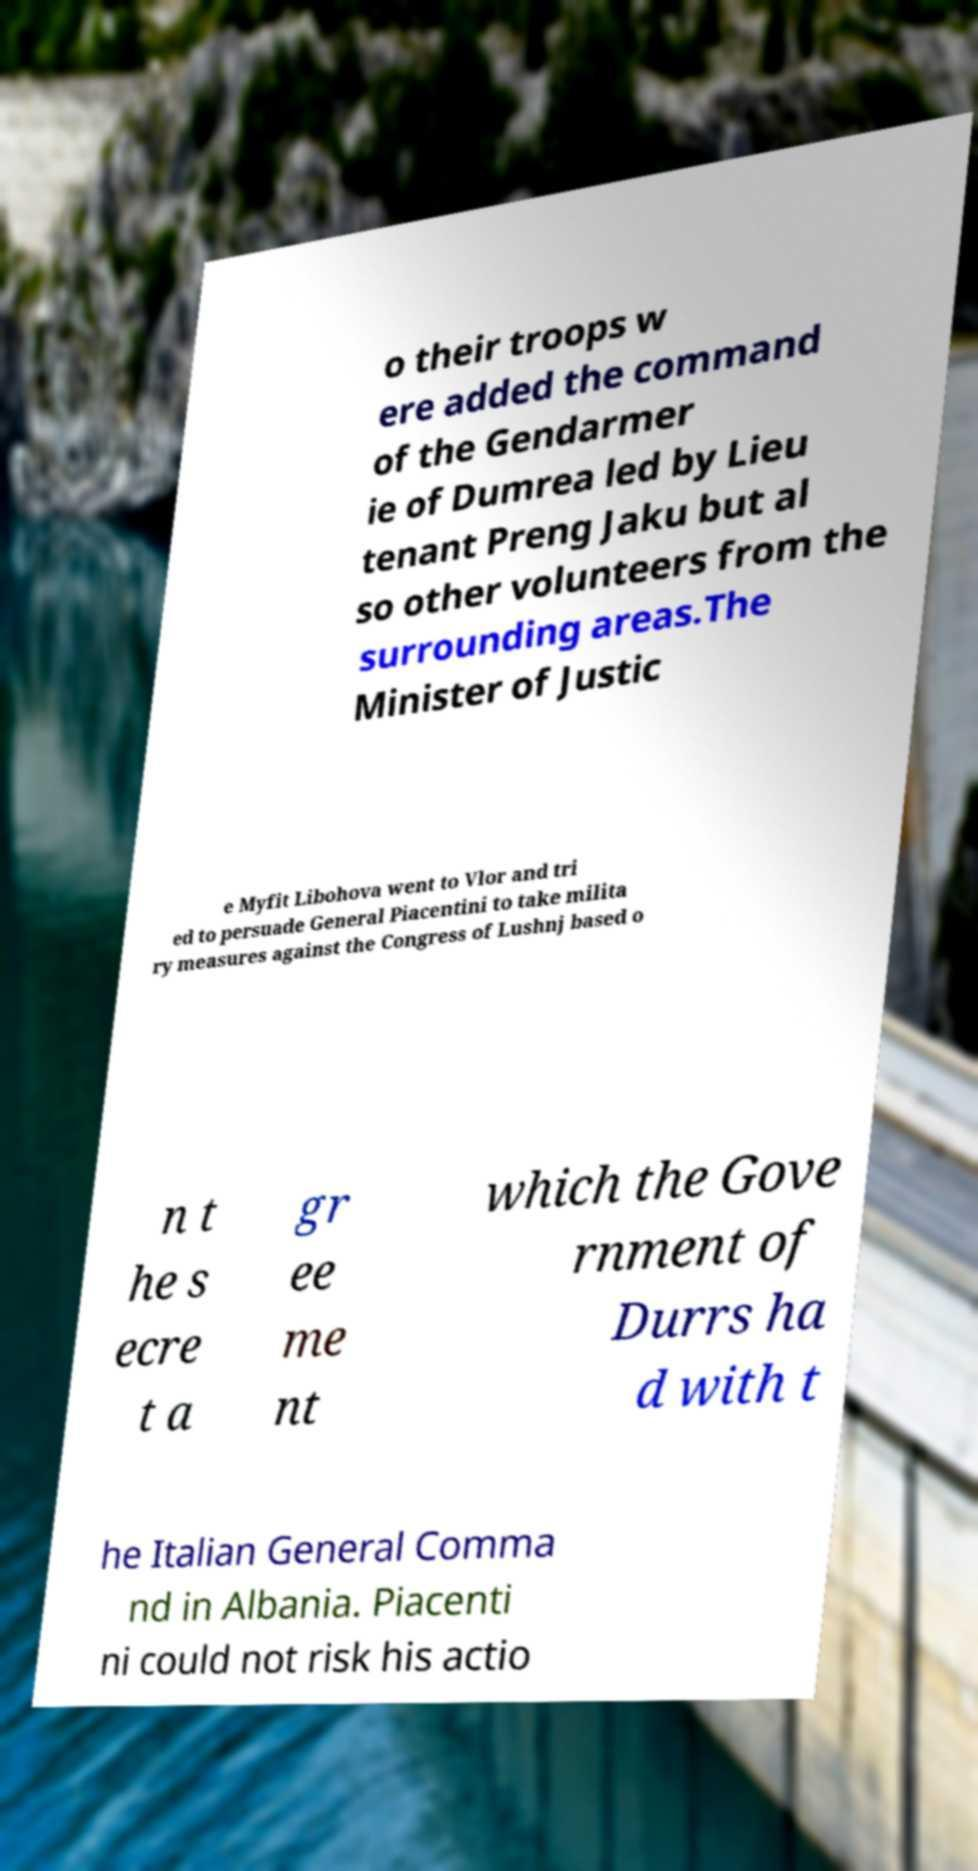Can you read and provide the text displayed in the image?This photo seems to have some interesting text. Can you extract and type it out for me? o their troops w ere added the command of the Gendarmer ie of Dumrea led by Lieu tenant Preng Jaku but al so other volunteers from the surrounding areas.The Minister of Justic e Myfit Libohova went to Vlor and tri ed to persuade General Piacentini to take milita ry measures against the Congress of Lushnj based o n t he s ecre t a gr ee me nt which the Gove rnment of Durrs ha d with t he Italian General Comma nd in Albania. Piacenti ni could not risk his actio 